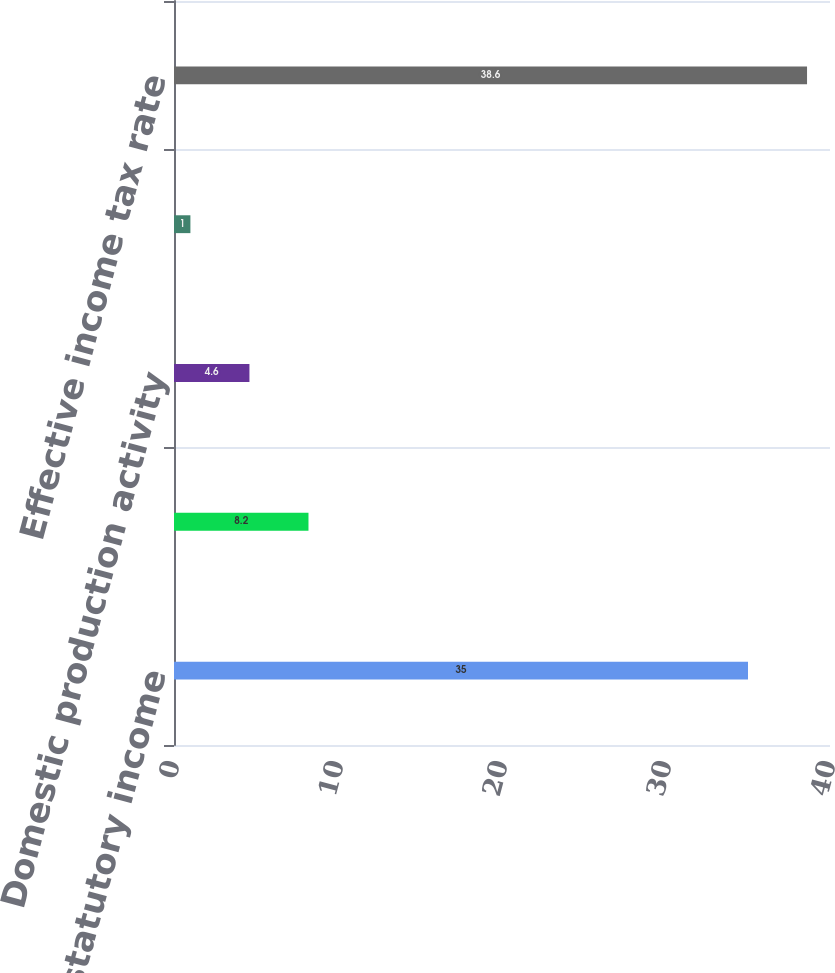Convert chart to OTSL. <chart><loc_0><loc_0><loc_500><loc_500><bar_chart><fcel>US federal statutory income<fcel>State and local income taxes<fcel>Domestic production activity<fcel>Other net<fcel>Effective income tax rate<nl><fcel>35<fcel>8.2<fcel>4.6<fcel>1<fcel>38.6<nl></chart> 